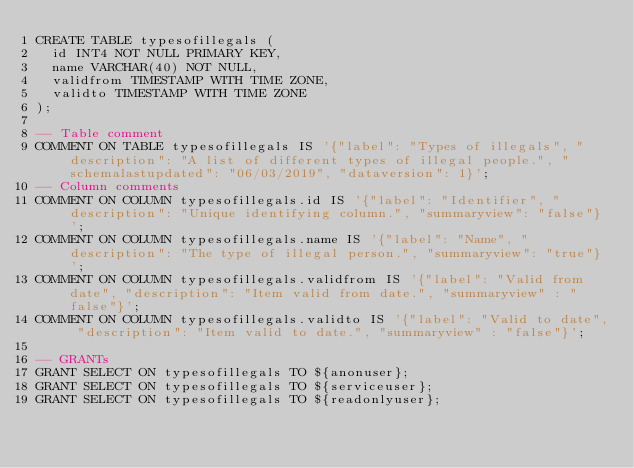<code> <loc_0><loc_0><loc_500><loc_500><_SQL_>CREATE TABLE typesofillegals (
  id INT4 NOT NULL PRIMARY KEY,
  name VARCHAR(40) NOT NULL,
  validfrom TIMESTAMP WITH TIME ZONE,
  validto TIMESTAMP WITH TIME ZONE
);

-- Table comment
COMMENT ON TABLE typesofillegals IS '{"label": "Types of illegals", "description": "A list of different types of illegal people.", "schemalastupdated": "06/03/2019", "dataversion": 1}';
-- Column comments
COMMENT ON COLUMN typesofillegals.id IS '{"label": "Identifier", "description": "Unique identifying column.", "summaryview": "false"}';
COMMENT ON COLUMN typesofillegals.name IS '{"label": "Name", "description": "The type of illegal person.", "summaryview": "true"}';
COMMENT ON COLUMN typesofillegals.validfrom IS '{"label": "Valid from date", "description": "Item valid from date.", "summaryview" : "false"}';
COMMENT ON COLUMN typesofillegals.validto IS '{"label": "Valid to date", "description": "Item valid to date.", "summaryview" : "false"}';

-- GRANTs
GRANT SELECT ON typesofillegals TO ${anonuser};
GRANT SELECT ON typesofillegals TO ${serviceuser};
GRANT SELECT ON typesofillegals TO ${readonlyuser};</code> 